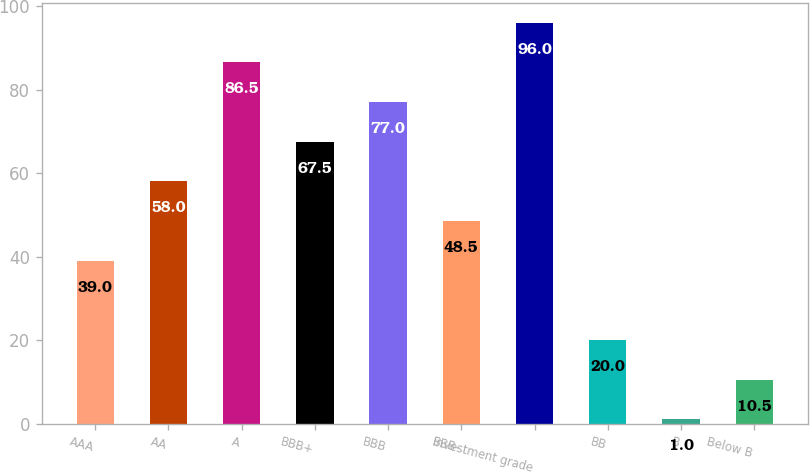Convert chart. <chart><loc_0><loc_0><loc_500><loc_500><bar_chart><fcel>AAA<fcel>AA<fcel>A<fcel>BBB+<fcel>BBB<fcel>BBB-<fcel>Investment grade<fcel>BB<fcel>B<fcel>Below B<nl><fcel>39<fcel>58<fcel>86.5<fcel>67.5<fcel>77<fcel>48.5<fcel>96<fcel>20<fcel>1<fcel>10.5<nl></chart> 